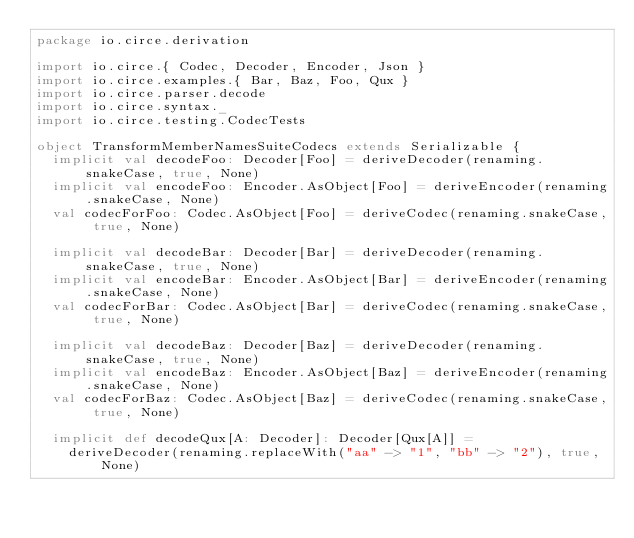Convert code to text. <code><loc_0><loc_0><loc_500><loc_500><_Scala_>package io.circe.derivation

import io.circe.{ Codec, Decoder, Encoder, Json }
import io.circe.examples.{ Bar, Baz, Foo, Qux }
import io.circe.parser.decode
import io.circe.syntax._
import io.circe.testing.CodecTests

object TransformMemberNamesSuiteCodecs extends Serializable {
  implicit val decodeFoo: Decoder[Foo] = deriveDecoder(renaming.snakeCase, true, None)
  implicit val encodeFoo: Encoder.AsObject[Foo] = deriveEncoder(renaming.snakeCase, None)
  val codecForFoo: Codec.AsObject[Foo] = deriveCodec(renaming.snakeCase, true, None)

  implicit val decodeBar: Decoder[Bar] = deriveDecoder(renaming.snakeCase, true, None)
  implicit val encodeBar: Encoder.AsObject[Bar] = deriveEncoder(renaming.snakeCase, None)
  val codecForBar: Codec.AsObject[Bar] = deriveCodec(renaming.snakeCase, true, None)

  implicit val decodeBaz: Decoder[Baz] = deriveDecoder(renaming.snakeCase, true, None)
  implicit val encodeBaz: Encoder.AsObject[Baz] = deriveEncoder(renaming.snakeCase, None)
  val codecForBaz: Codec.AsObject[Baz] = deriveCodec(renaming.snakeCase, true, None)

  implicit def decodeQux[A: Decoder]: Decoder[Qux[A]] =
    deriveDecoder(renaming.replaceWith("aa" -> "1", "bb" -> "2"), true, None)</code> 